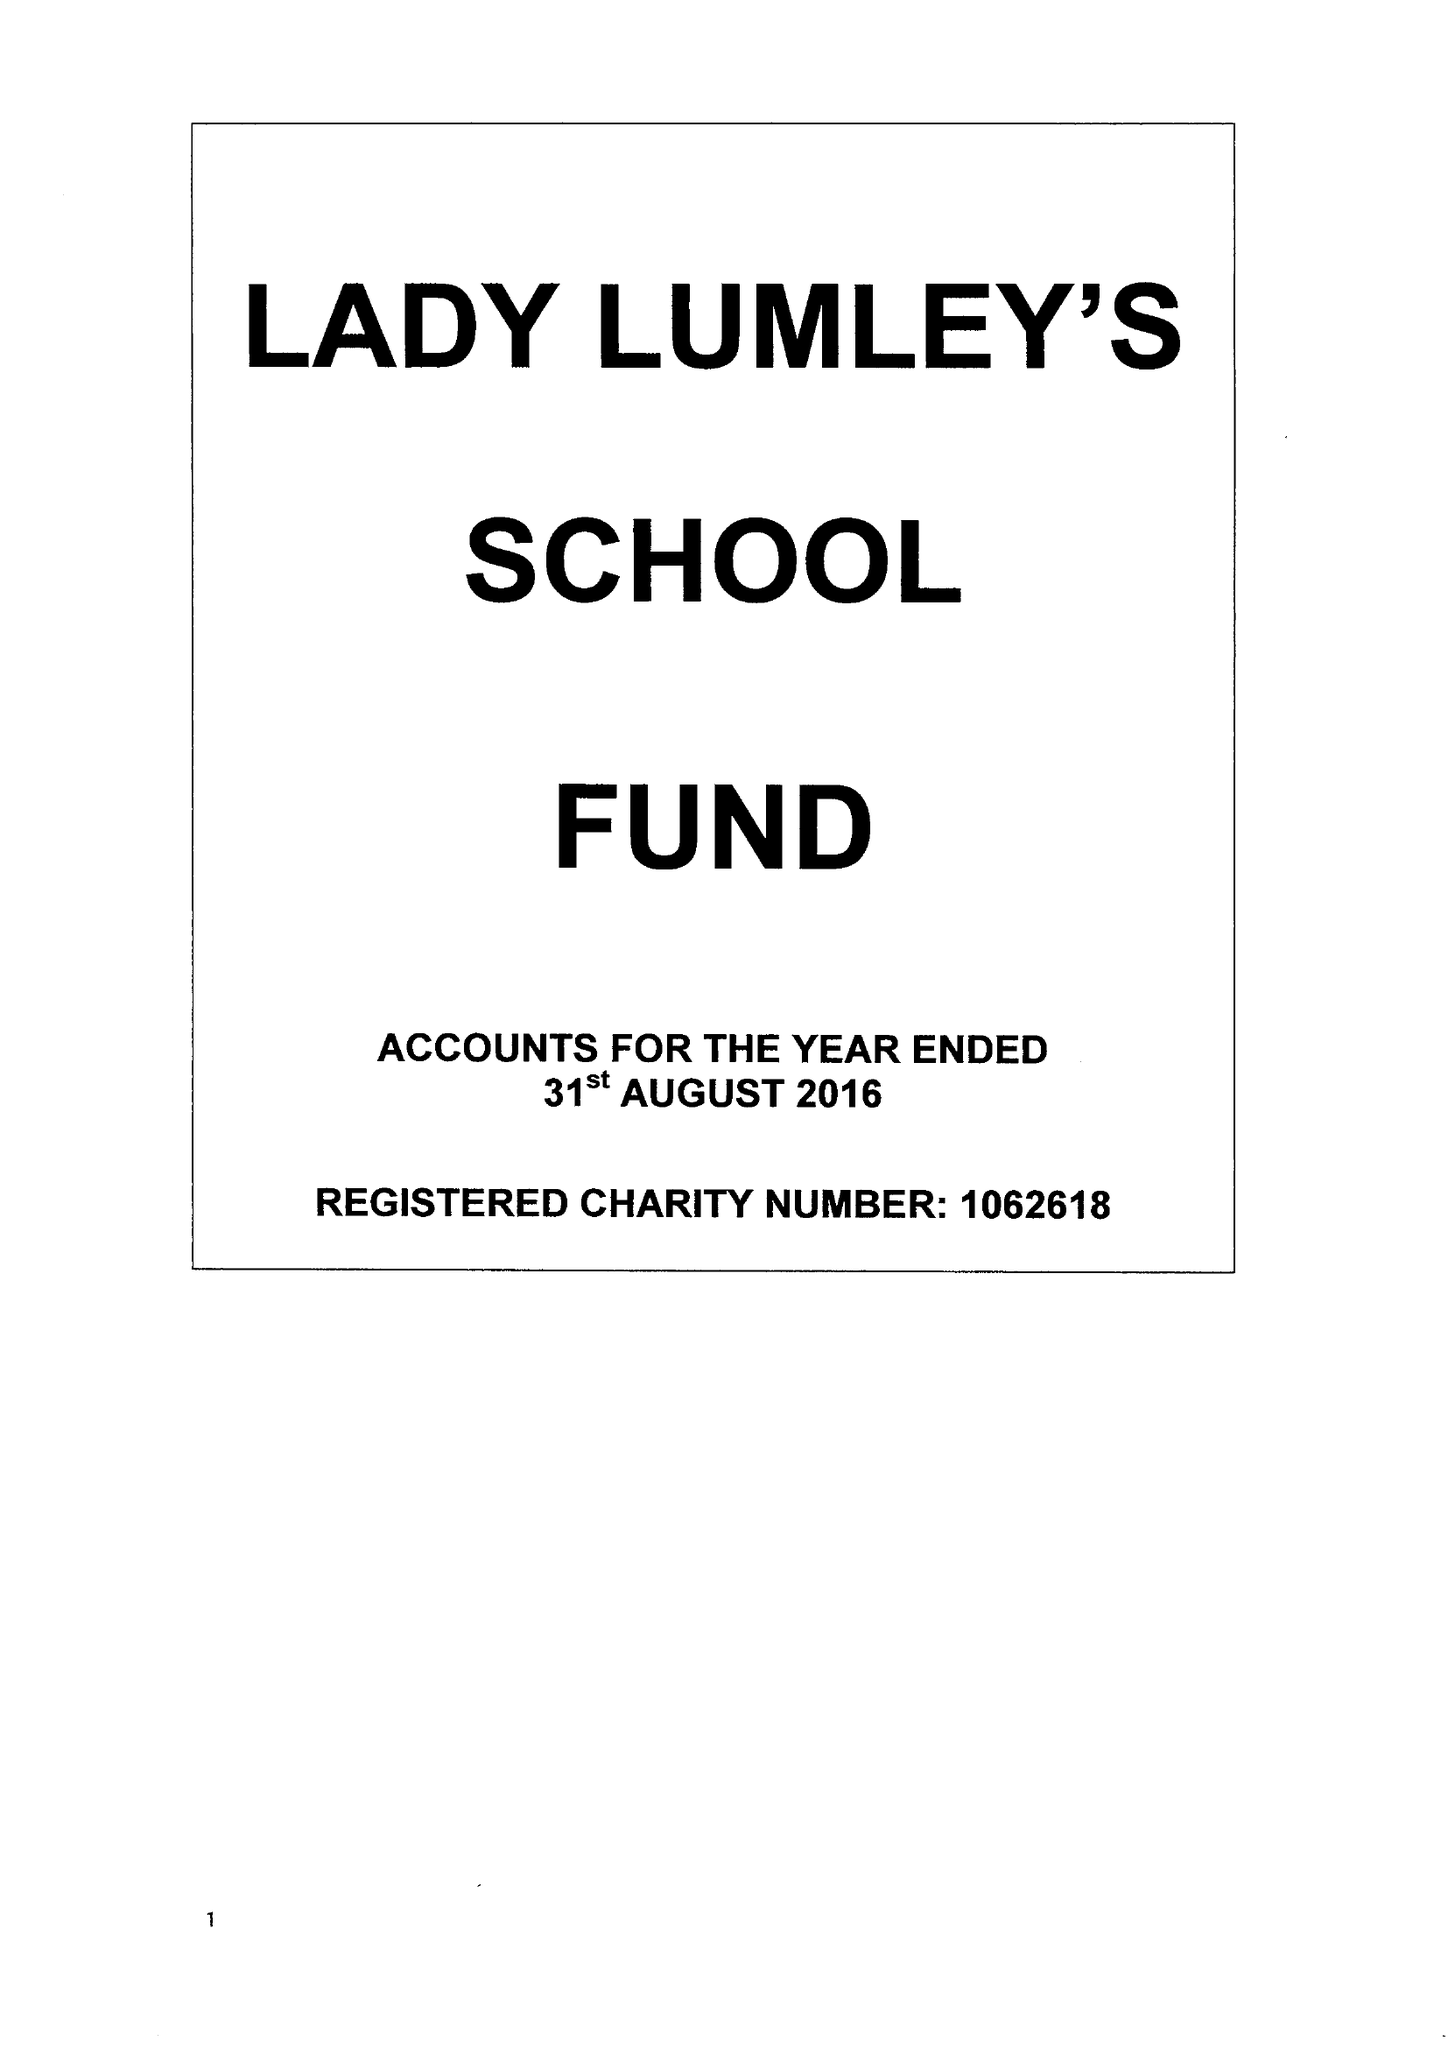What is the value for the address__postcode?
Answer the question using a single word or phrase. YO18 8NG 